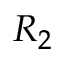<formula> <loc_0><loc_0><loc_500><loc_500>R _ { 2 }</formula> 